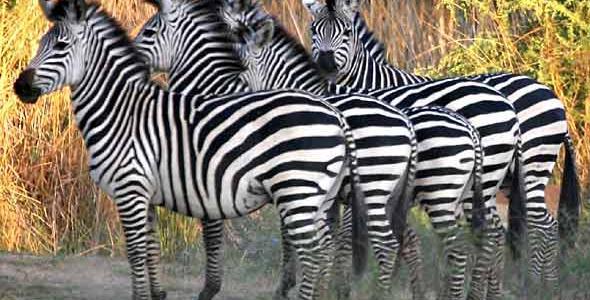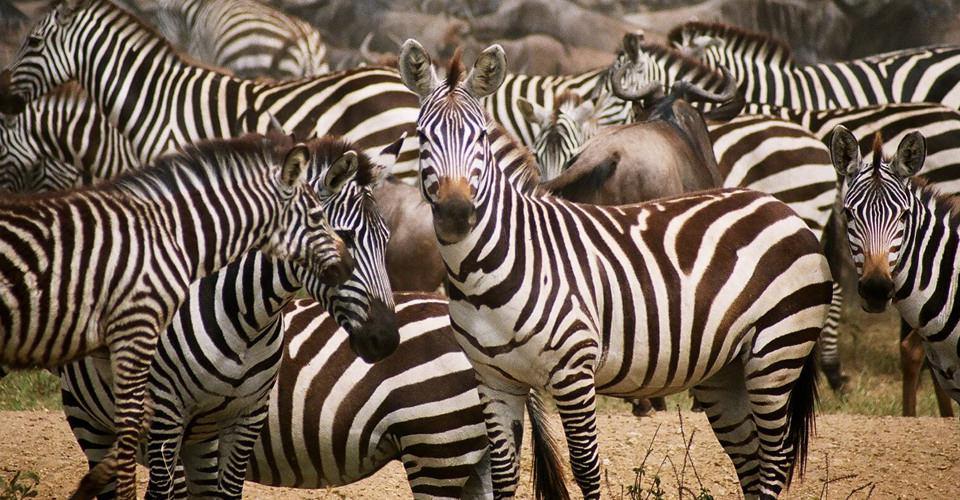The first image is the image on the left, the second image is the image on the right. For the images displayed, is the sentence "The left image includes a row of leftward-facing zebras standing in water and bending their necks to drink." factually correct? Answer yes or no. No. The first image is the image on the left, the second image is the image on the right. Examine the images to the left and right. Is the description "Some of the zebras are standing in water in one of the images." accurate? Answer yes or no. No. 